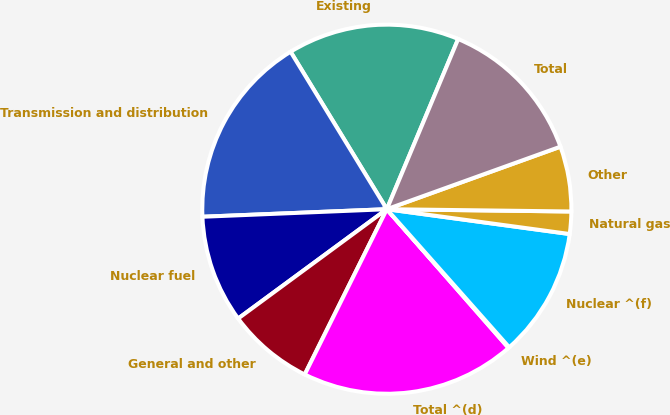Convert chart to OTSL. <chart><loc_0><loc_0><loc_500><loc_500><pie_chart><fcel>Existing<fcel>Transmission and distribution<fcel>Nuclear fuel<fcel>General and other<fcel>Total ^(d)<fcel>Wind ^(e)<fcel>Nuclear ^(f)<fcel>Natural gas<fcel>Other<fcel>Total<nl><fcel>15.05%<fcel>16.92%<fcel>9.44%<fcel>7.57%<fcel>18.8%<fcel>0.08%<fcel>11.31%<fcel>1.95%<fcel>5.7%<fcel>13.18%<nl></chart> 